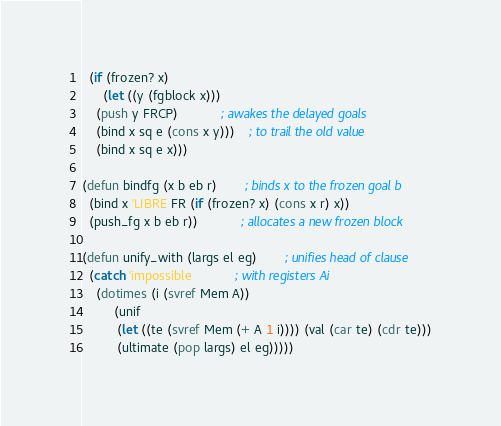<code> <loc_0><loc_0><loc_500><loc_500><_Lisp_>  (if (frozen? x)
      (let ((y (fgblock x)))
	(push y FRCP)			; awakes the delayed goals
	(bind x sq e (cons x y)))	; to trail the old value
    (bind x sq e x)))

(defun bindfg (x b eb r)		; binds x to the frozen goal b
  (bind x 'LIBRE FR (if (frozen? x) (cons x r) x))
  (push_fg x b eb r))			; allocates a new frozen block

(defun unify_with (largs el eg)		; unifies head of clause
  (catch 'impossible			; with registers Ai
    (dotimes (i (svref Mem A))
	     (unif
	      (let ((te (svref Mem (+ A 1 i)))) (val (car te) (cdr te)))
	      (ultimate (pop largs) el eg)))))

</code> 